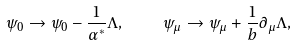Convert formula to latex. <formula><loc_0><loc_0><loc_500><loc_500>\psi _ { 0 } \to \psi _ { 0 } - \frac { 1 } { \alpha ^ { * } } \Lambda , \quad \psi _ { \mu } \to \psi _ { \mu } + \frac { 1 } { b } \partial _ { \mu } \Lambda ,</formula> 